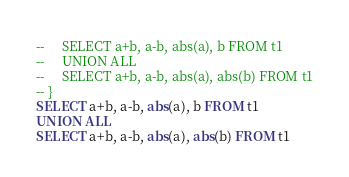<code> <loc_0><loc_0><loc_500><loc_500><_SQL_>--     SELECT a+b, a-b, abs(a), b FROM t1
--     UNION ALL
--     SELECT a+b, a-b, abs(a), abs(b) FROM t1
-- }
SELECT a+b, a-b, abs(a), b FROM t1
UNION ALL
SELECT a+b, a-b, abs(a), abs(b) FROM t1</code> 